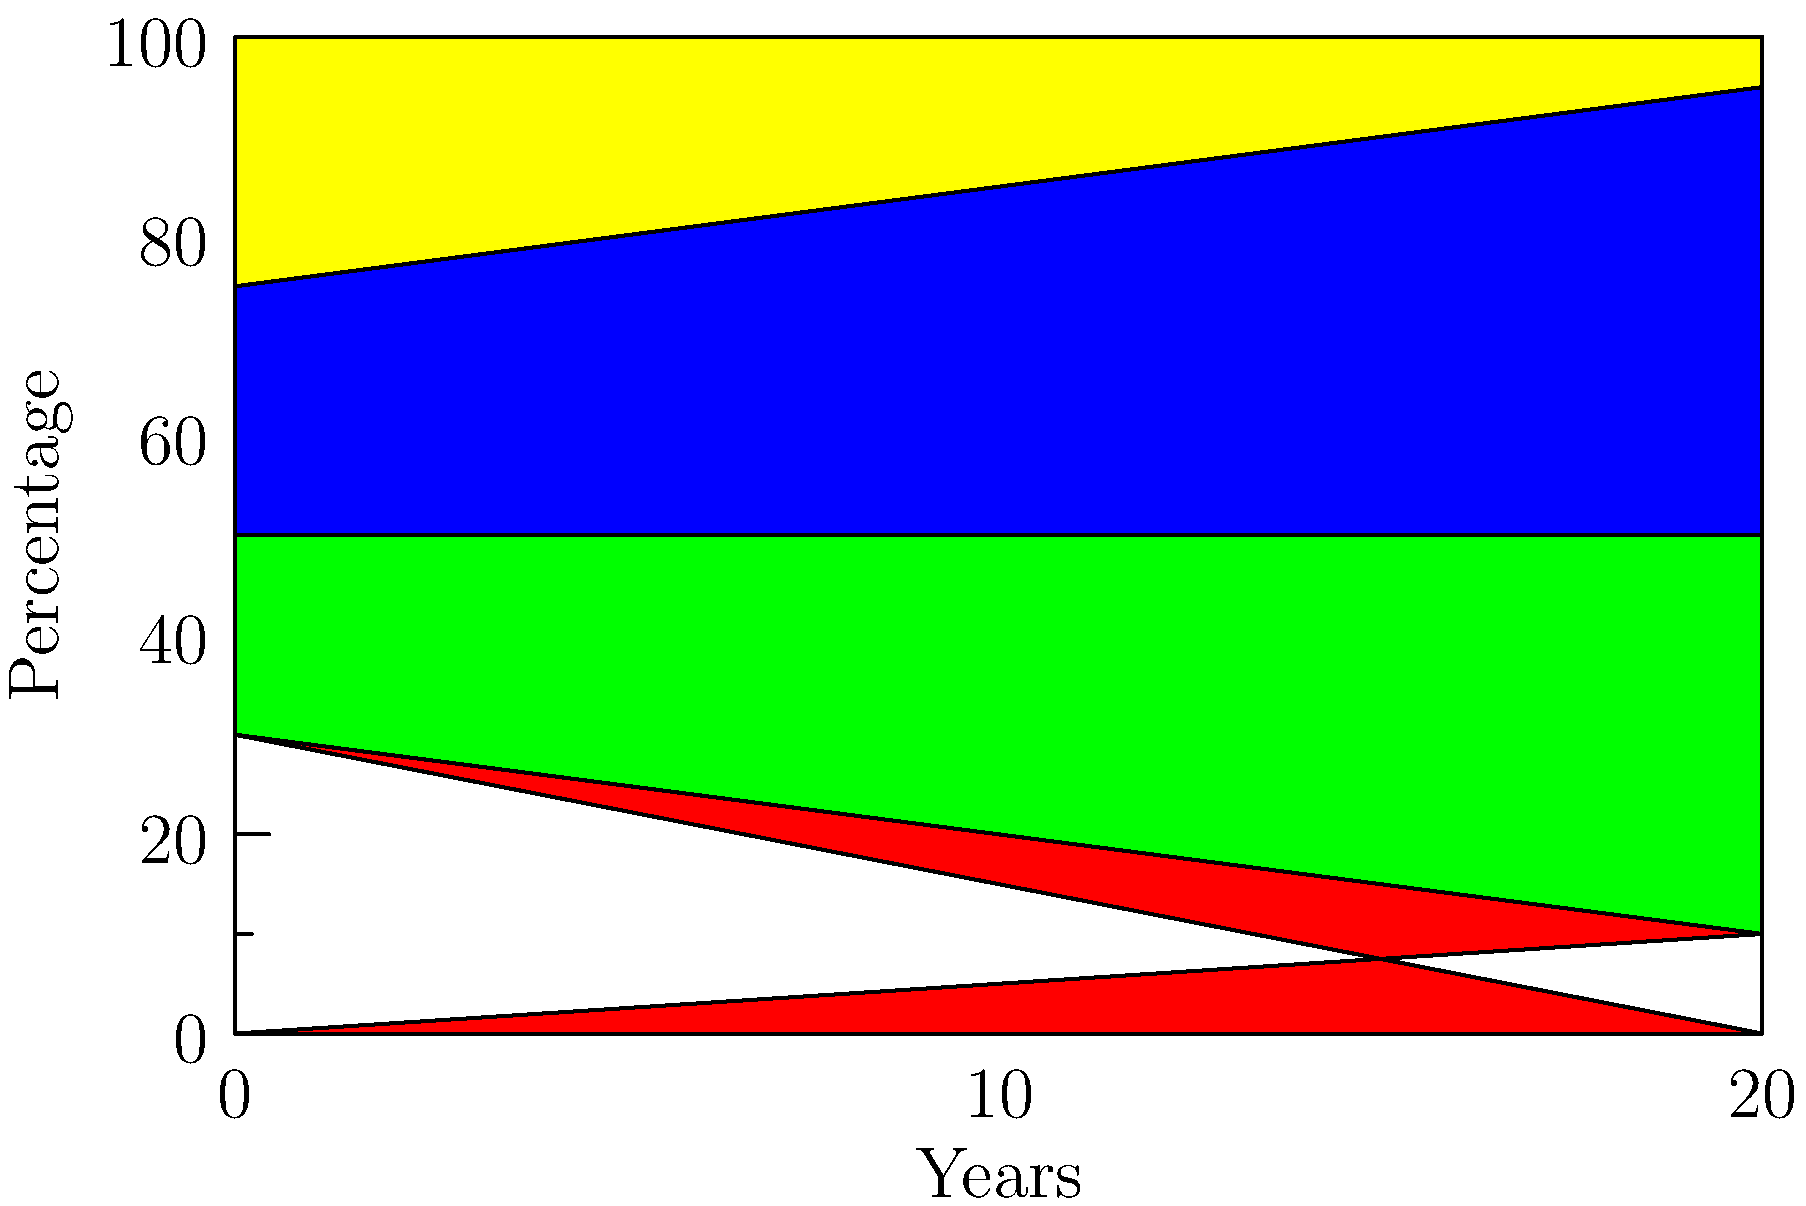Based on the stacked area chart showing the progression of lifestyle factors over 20 years, which factor demonstrates the most significant increase, potentially contributing to chronic disease progression? To answer this question, we need to analyze the trends of each lifestyle factor over the 20-year period:

1. Smoking (red area):
   - Starts at 30% and decreases to 10%
   - Shows a consistent downward trend

2. Obesity (green area):
   - Starts at 20% and increases to 40%
   - Shows a steady upward trend

3. Sedentary lifestyle (blue area):
   - Starts at 25% and increases to 45%
   - Shows the most significant increase among all factors

4. Healthy lifestyle (yellow area):
   - Starts at 25% and decreases to 5%
   - Shows a consistent downward trend

Comparing these trends, we can see that the sedentary lifestyle factor demonstrates the most significant increase over the 20-year period, rising from 25% to 45%. This represents a 20 percentage point increase, which is the largest change among all factors.

The obesity factor also shows an increase, but it's slightly less pronounced, rising from 20% to 40% (a 20 percentage point increase as well, but starting from a lower baseline).

In contrast, smoking and healthy lifestyle factors both show decreasing trends.

Given that sedentary lifestyle has the most substantial increase and is known to be a risk factor for various chronic diseases, it is likely to have the most significant impact on chronic disease progression based on this data.
Answer: Sedentary lifestyle 